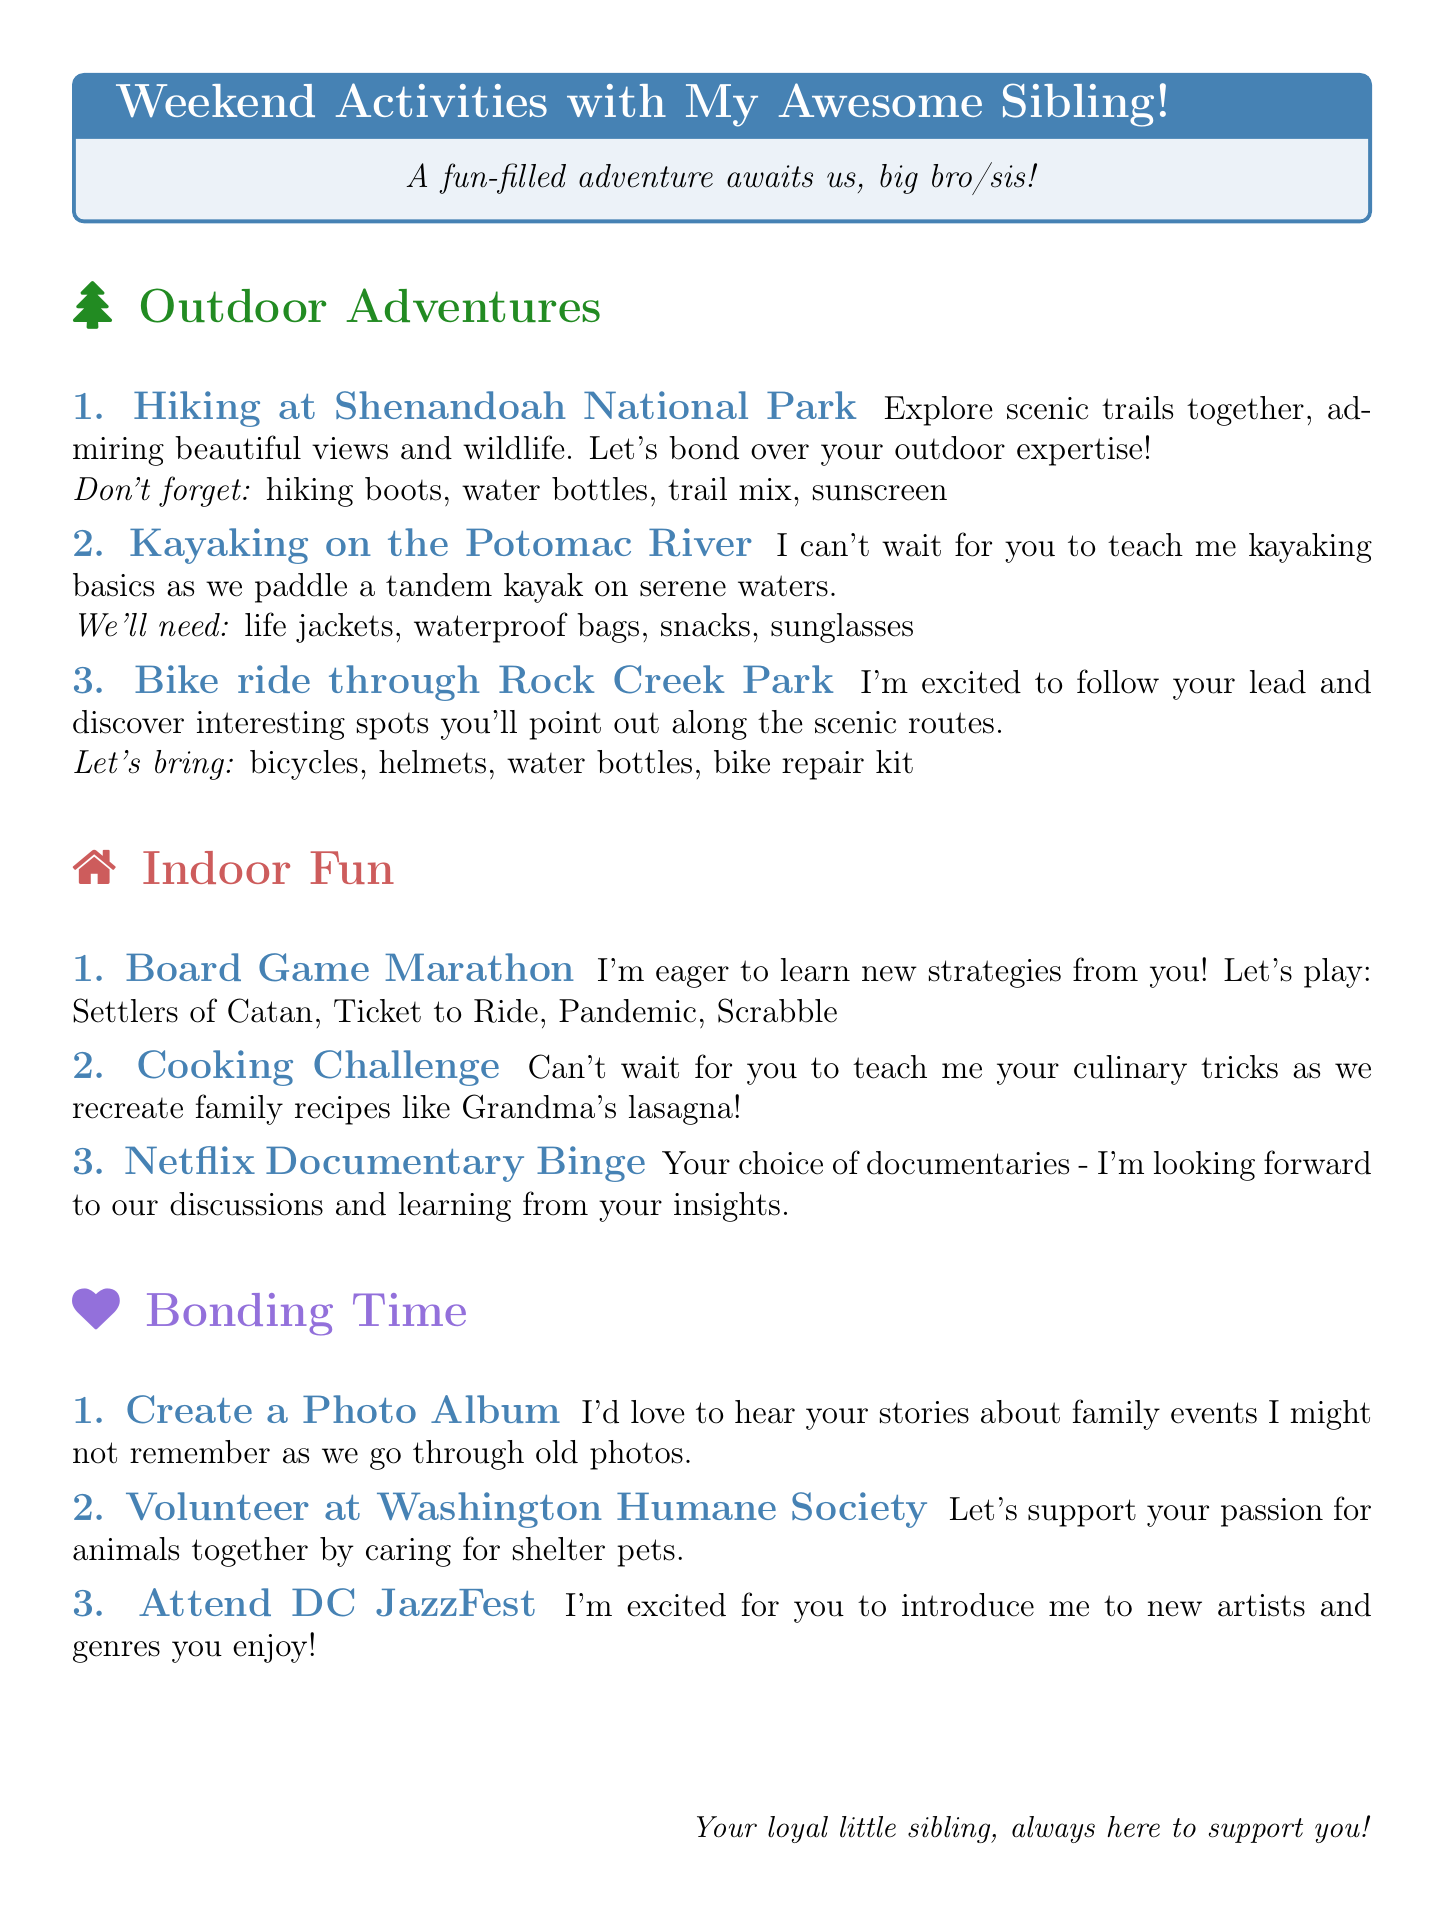What is one outdoor activity suggested for the weekend? The document lists various outdoor activities, and one example is "Hiking at Shenandoah National Park."
Answer: Hiking at Shenandoah National Park What is a game included in the board game marathon? The document suggests several games for the board game marathon, including "Settlers of Catan."
Answer: Settlers of Catan What materials are needed to create a photo album? The document lists materials for the photo album activity, which include "photo album, printed photos, markers, decorative stickers."
Answer: photo album, printed photos, markers, decorative stickers What is the name of the shelter to volunteer at? The document provides a suggestion for volunteering, which is "Washington Humane Society."
Answer: Washington Humane Society How many indoor activities are mentioned? The document outlines three indoor activities, such as board game marathon and cooking challenge.
Answer: 3 What are we expected to learn from the kayaking activity? The document indicates that during kayaking, the older sibling will guide you through the basics of kayaking.
Answer: basics of kayaking What is a bonding activity that involves going through old family photos? The document mentions "Create a photo album" as an activity involving family photos.
Answer: Create a photo album Which activity allows the younger sibling to learn from the older sibling's culinary skills? The document lists the "Cooking challenge" as a culinary learning activity.
Answer: Cooking challenge 